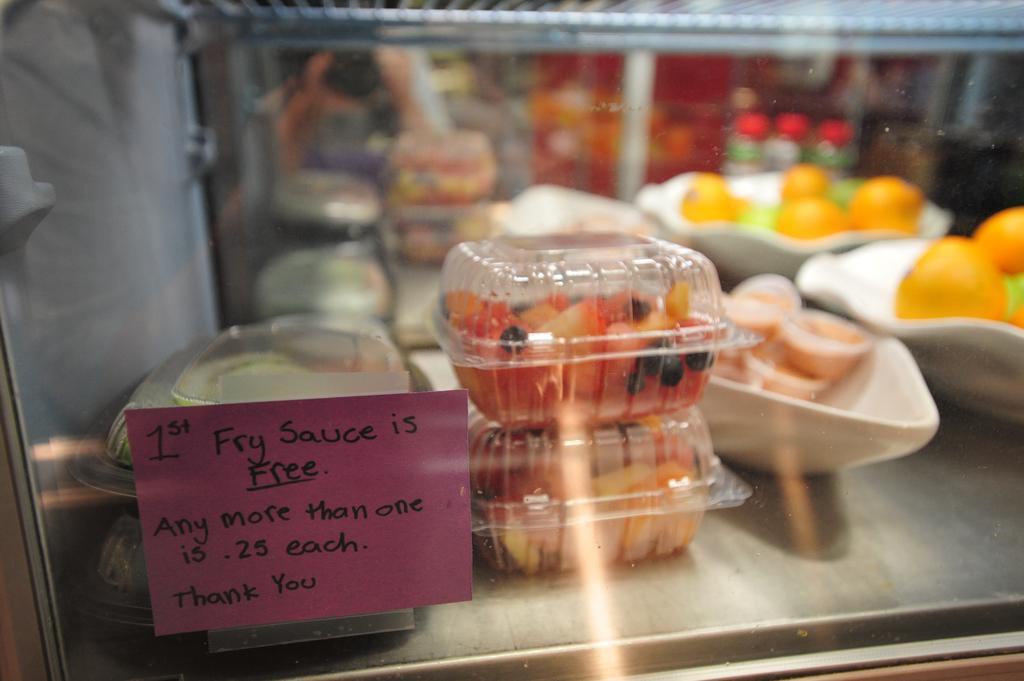In one or two sentences, can you explain what this image depicts? In this image there is a glass through which we can see the fruits and food items in the bowl. 